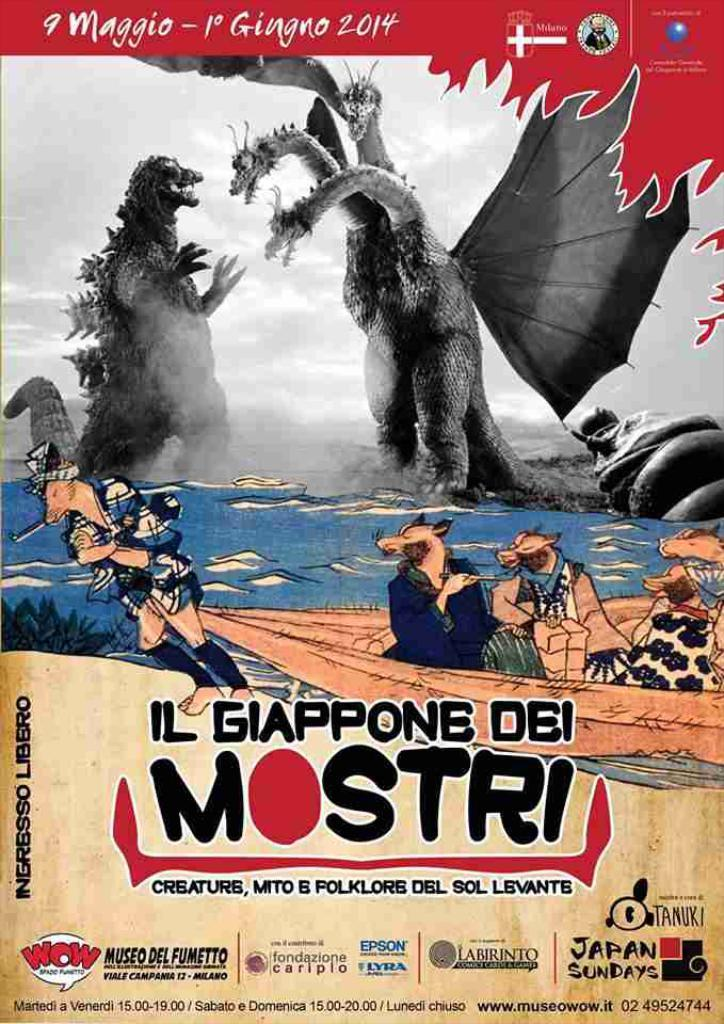<image>
Summarize the visual content of the image. a movie poster that has Mostri on it 